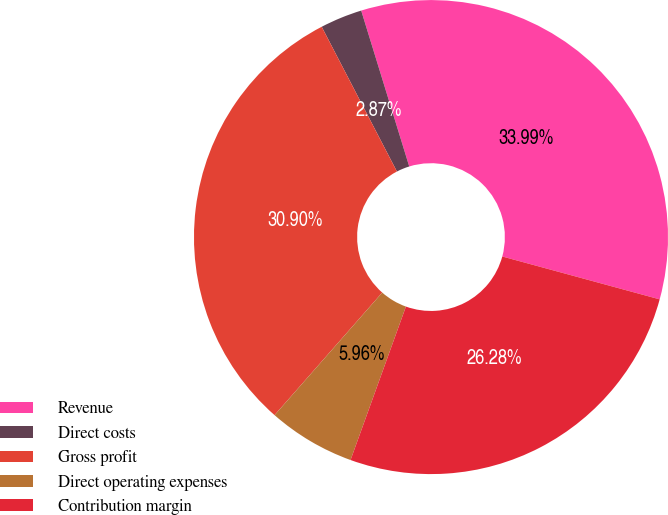Convert chart to OTSL. <chart><loc_0><loc_0><loc_500><loc_500><pie_chart><fcel>Revenue<fcel>Direct costs<fcel>Gross profit<fcel>Direct operating expenses<fcel>Contribution margin<nl><fcel>33.99%<fcel>2.87%<fcel>30.9%<fcel>5.96%<fcel>26.28%<nl></chart> 